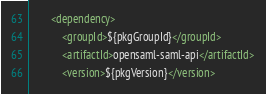Convert code to text. <code><loc_0><loc_0><loc_500><loc_500><_XML_>        <dependency>
            <groupId>${pkgGroupId}</groupId>
            <artifactId>opensaml-saml-api</artifactId>
            <version>${pkgVersion}</version></code> 